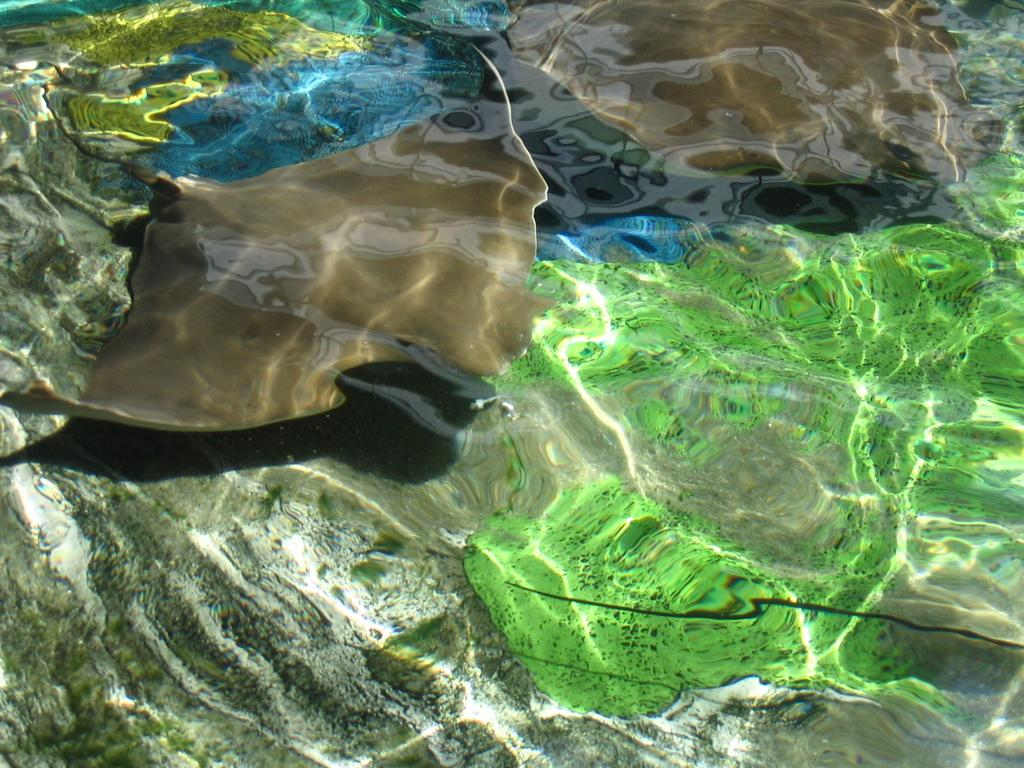What type of animal is in the image? There is a fish in the image. What color is the fish? The fish is in brown color. What else can be seen in the water besides the fish? There is green color debris in the water. What is the primary element visible in the image? There is water visible in the image. What type of gun is being used to catch the fish in the image? There is no gun present in the image; it only features a fish in brown color and green debris in the water. 